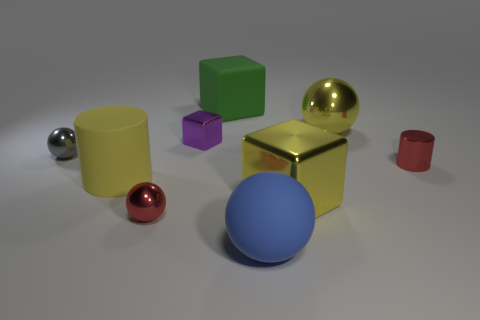Can you tell me how many objects are in this image? Certainly! There are seven objects in this image, each with a unique color and several with distinct shapes.  Are there more spherical objects or cubic objects? In this image, spherical objects are more numerous, counting three in total, compared to just one cube. 